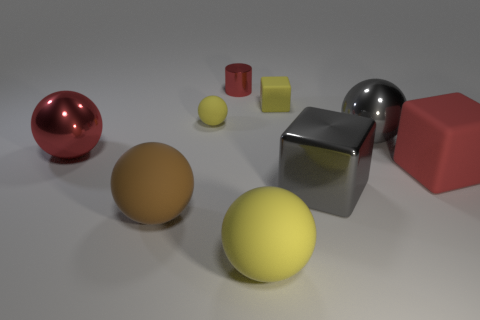Is the large brown thing the same shape as the large yellow rubber object?
Your answer should be very brief. Yes. How many cylinders are either tiny green matte things or tiny red things?
Your answer should be very brief. 1. What is the size of the shiny object that is the same color as the large metal block?
Keep it short and to the point. Large. Are there fewer large balls on the right side of the tiny metallic cylinder than red matte cylinders?
Keep it short and to the point. No. The large sphere that is behind the big brown matte sphere and to the right of the red cylinder is what color?
Your answer should be compact. Gray. What number of other things are there of the same shape as the brown object?
Keep it short and to the point. 4. Are there fewer small yellow rubber things that are right of the gray metal block than cubes to the left of the brown matte ball?
Provide a succinct answer. No. Is the large red sphere made of the same material as the gray object that is behind the large red shiny ball?
Make the answer very short. Yes. Is there anything else that has the same material as the brown thing?
Provide a short and direct response. Yes. Is the number of cubes greater than the number of small red shiny objects?
Your answer should be compact. Yes. 